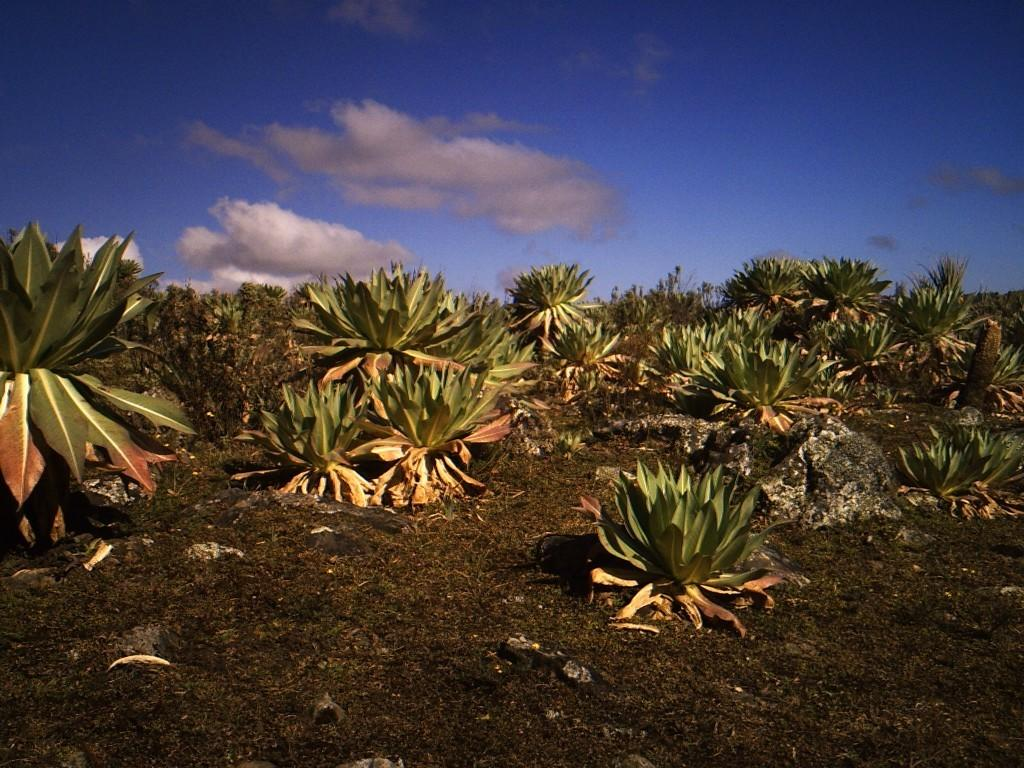What type of vegetation is in the front of the image? There are plants and grass in the front of the image. What can be seen in the background of the image? There are clouds and the sky visible in the background of the image. What type of disease is affecting the plants in the image? There is no indication of any disease affecting the plants in the image. What is the texture of the clouds in the image? The texture of the clouds cannot be determined from the image alone, as it is a 2D representation. 